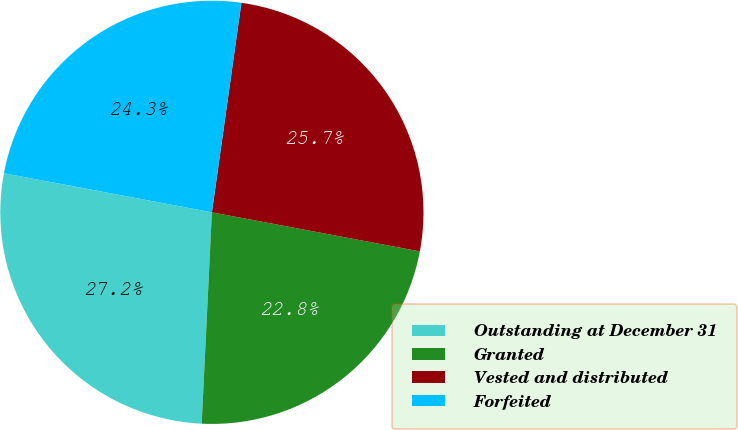Convert chart to OTSL. <chart><loc_0><loc_0><loc_500><loc_500><pie_chart><fcel>Outstanding at December 31<fcel>Granted<fcel>Vested and distributed<fcel>Forfeited<nl><fcel>27.19%<fcel>22.81%<fcel>25.73%<fcel>24.27%<nl></chart> 